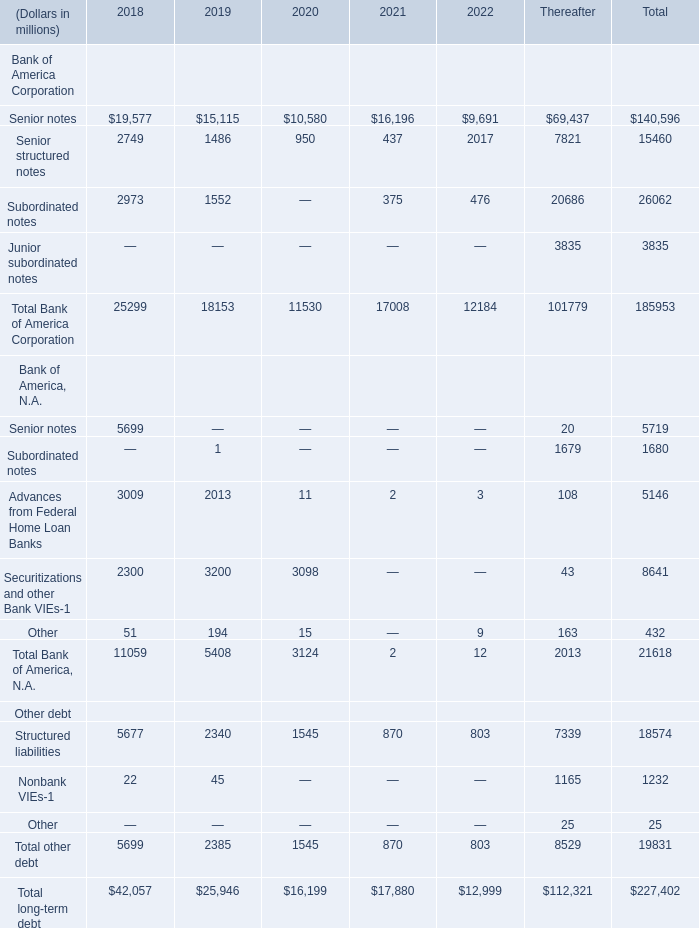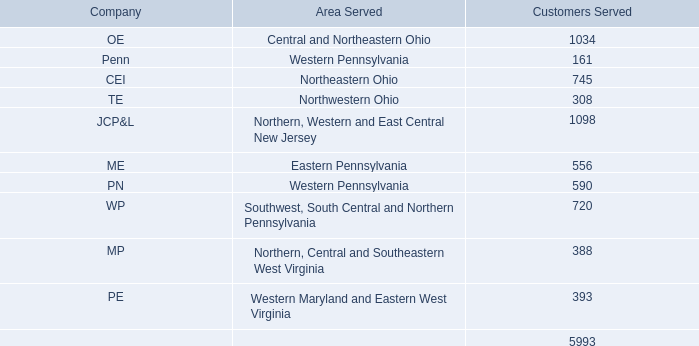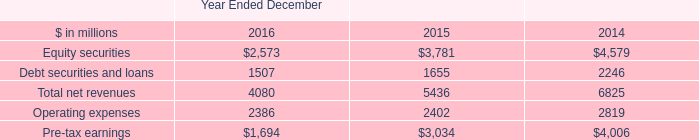What's the average of Senior notes in 2018? (in million) 
Computations: ((19577 + 5699) / 2)
Answer: 12638.0. 